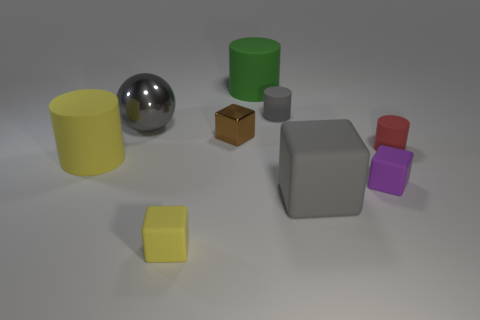Subtract all small brown shiny blocks. How many blocks are left? 3 Add 1 large yellow things. How many objects exist? 10 Subtract all gray cylinders. How many cylinders are left? 3 Subtract 2 blocks. How many blocks are left? 2 Subtract all cyan cylinders. Subtract all cyan cubes. How many cylinders are left? 4 Add 9 purple things. How many purple things are left? 10 Add 4 red matte cylinders. How many red matte cylinders exist? 5 Subtract 1 gray cubes. How many objects are left? 8 Subtract all balls. How many objects are left? 8 Subtract all tiny red shiny cylinders. Subtract all big metallic balls. How many objects are left? 8 